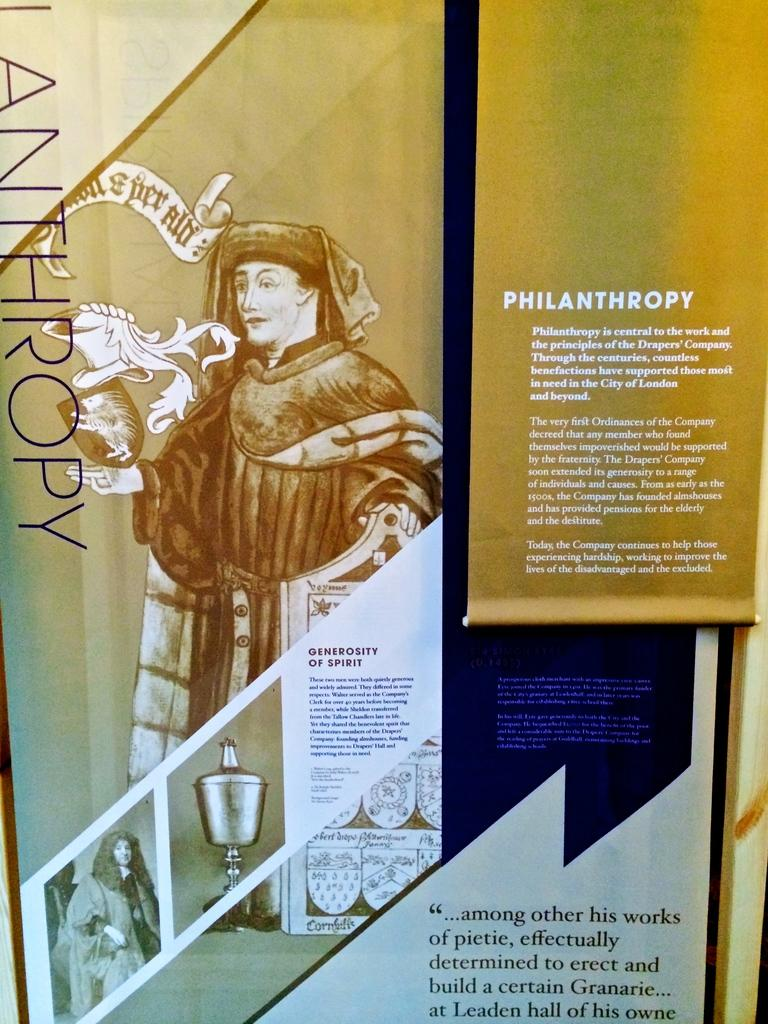What can be seen in the picture? There are images in the picture. What accompanies the images in the picture? There is writing beside the images. How many leaves are depicted in the image? There is no mention of leaves in the provided facts, so it cannot be determined from the image. 